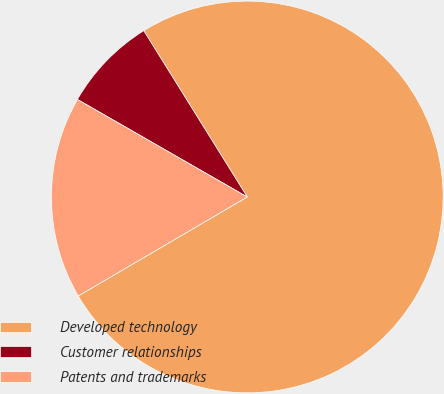Convert chart. <chart><loc_0><loc_0><loc_500><loc_500><pie_chart><fcel>Developed technology<fcel>Customer relationships<fcel>Patents and trademarks<nl><fcel>75.43%<fcel>7.84%<fcel>16.73%<nl></chart> 